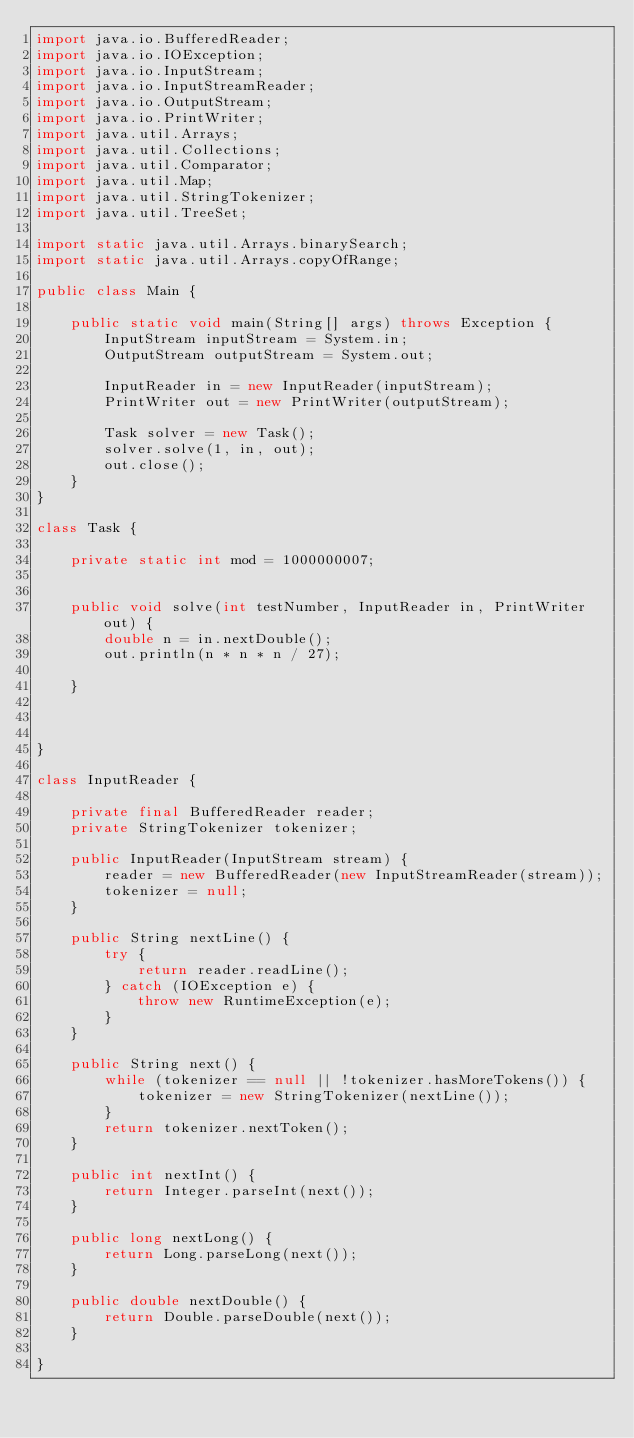<code> <loc_0><loc_0><loc_500><loc_500><_Java_>import java.io.BufferedReader;
import java.io.IOException;
import java.io.InputStream;
import java.io.InputStreamReader;
import java.io.OutputStream;
import java.io.PrintWriter;
import java.util.Arrays;
import java.util.Collections;
import java.util.Comparator;
import java.util.Map;
import java.util.StringTokenizer;
import java.util.TreeSet;

import static java.util.Arrays.binarySearch;
import static java.util.Arrays.copyOfRange;

public class Main {

    public static void main(String[] args) throws Exception {
        InputStream inputStream = System.in;
        OutputStream outputStream = System.out;

        InputReader in = new InputReader(inputStream);
        PrintWriter out = new PrintWriter(outputStream);

        Task solver = new Task();
        solver.solve(1, in, out);
        out.close();
    }
}

class Task {

    private static int mod = 1000000007;


    public void solve(int testNumber, InputReader in, PrintWriter out) {
        double n = in.nextDouble();
        out.println(n * n * n / 27);

    }



}

class InputReader {

    private final BufferedReader reader;
    private StringTokenizer tokenizer;

    public InputReader(InputStream stream) {
        reader = new BufferedReader(new InputStreamReader(stream));
        tokenizer = null;
    }

    public String nextLine() {
        try {
            return reader.readLine();
        } catch (IOException e) {
            throw new RuntimeException(e);
        }
    }

    public String next() {
        while (tokenizer == null || !tokenizer.hasMoreTokens()) {
            tokenizer = new StringTokenizer(nextLine());
        }
        return tokenizer.nextToken();
    }

    public int nextInt() {
        return Integer.parseInt(next());
    }

    public long nextLong() {
        return Long.parseLong(next());
    }

    public double nextDouble() {
        return Double.parseDouble(next());
    }

}
</code> 